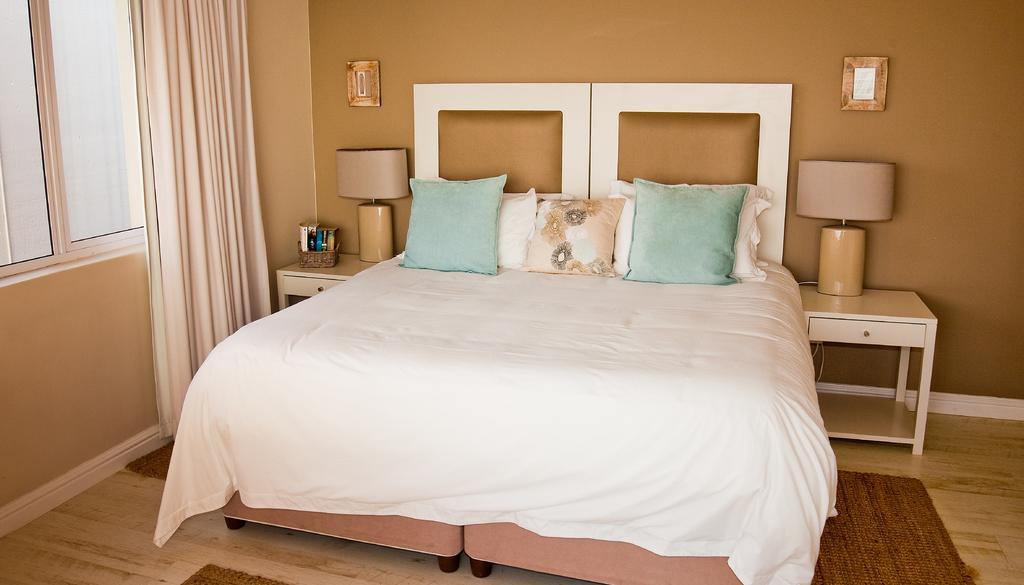Can you describe this image briefly? In the middle of the image there is bed, On the bed there are pillows. Right side of the image there is a table, On the table there is a lamp. Left side of the image there is a table, On the table there is a lamp. Beside the lamp there are some products. Top left side of the image there is a curtain. Behind the curtain there is a glass window. Bottom left side of the image There is mat and bottom right side of the image also there is mat. 